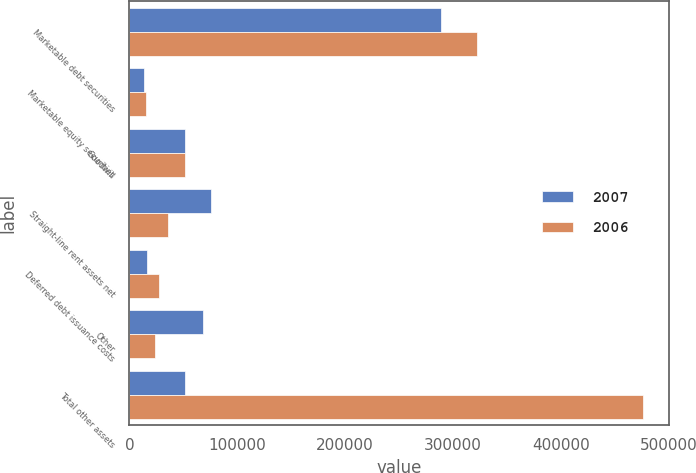<chart> <loc_0><loc_0><loc_500><loc_500><stacked_bar_chart><ecel><fcel>Marketable debt securities<fcel>Marketable equity securities<fcel>Goodwill<fcel>Straight-line rent assets net<fcel>Deferred debt issuance costs<fcel>Other<fcel>Total other assets<nl><fcel>2007<fcel>289163<fcel>13761<fcel>51746<fcel>76188<fcel>16787<fcel>68488<fcel>51746<nl><fcel>2006<fcel>322500<fcel>15159<fcel>51746<fcel>35582<fcel>27499<fcel>23849<fcel>476335<nl></chart> 